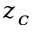<formula> <loc_0><loc_0><loc_500><loc_500>z _ { c }</formula> 